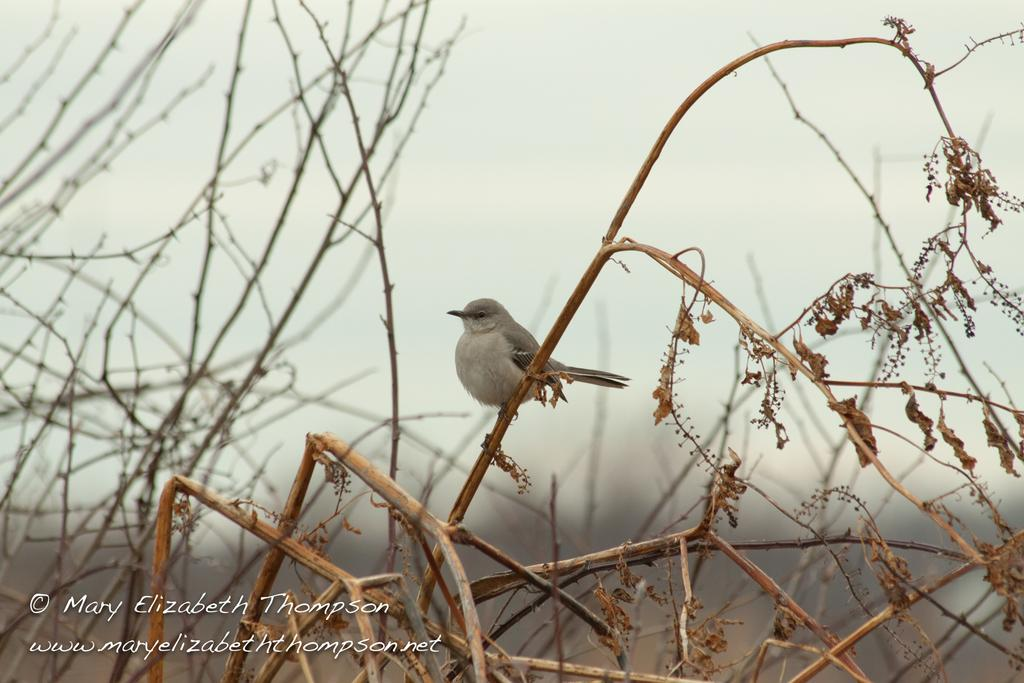What type of animal is present in the image? There is a bird in the image. What else can be seen in the image besides the bird? There are stems and leaves in the image. What part of the natural environment is visible in the image? The sky is visible in the image. What is present in the bottom left corner of the image? There is some text and a watermark in the bottom left corner of the image. How would you describe the background of the image? The background of the image is blurry. What type of discussion is taking place in the image? There is no discussion taking place in the image; it features a bird, stems and leaves, and a blurry background. Can you see any lipstick on the bird in the image? There is no lipstick or any indication of lips on the bird in the image. 